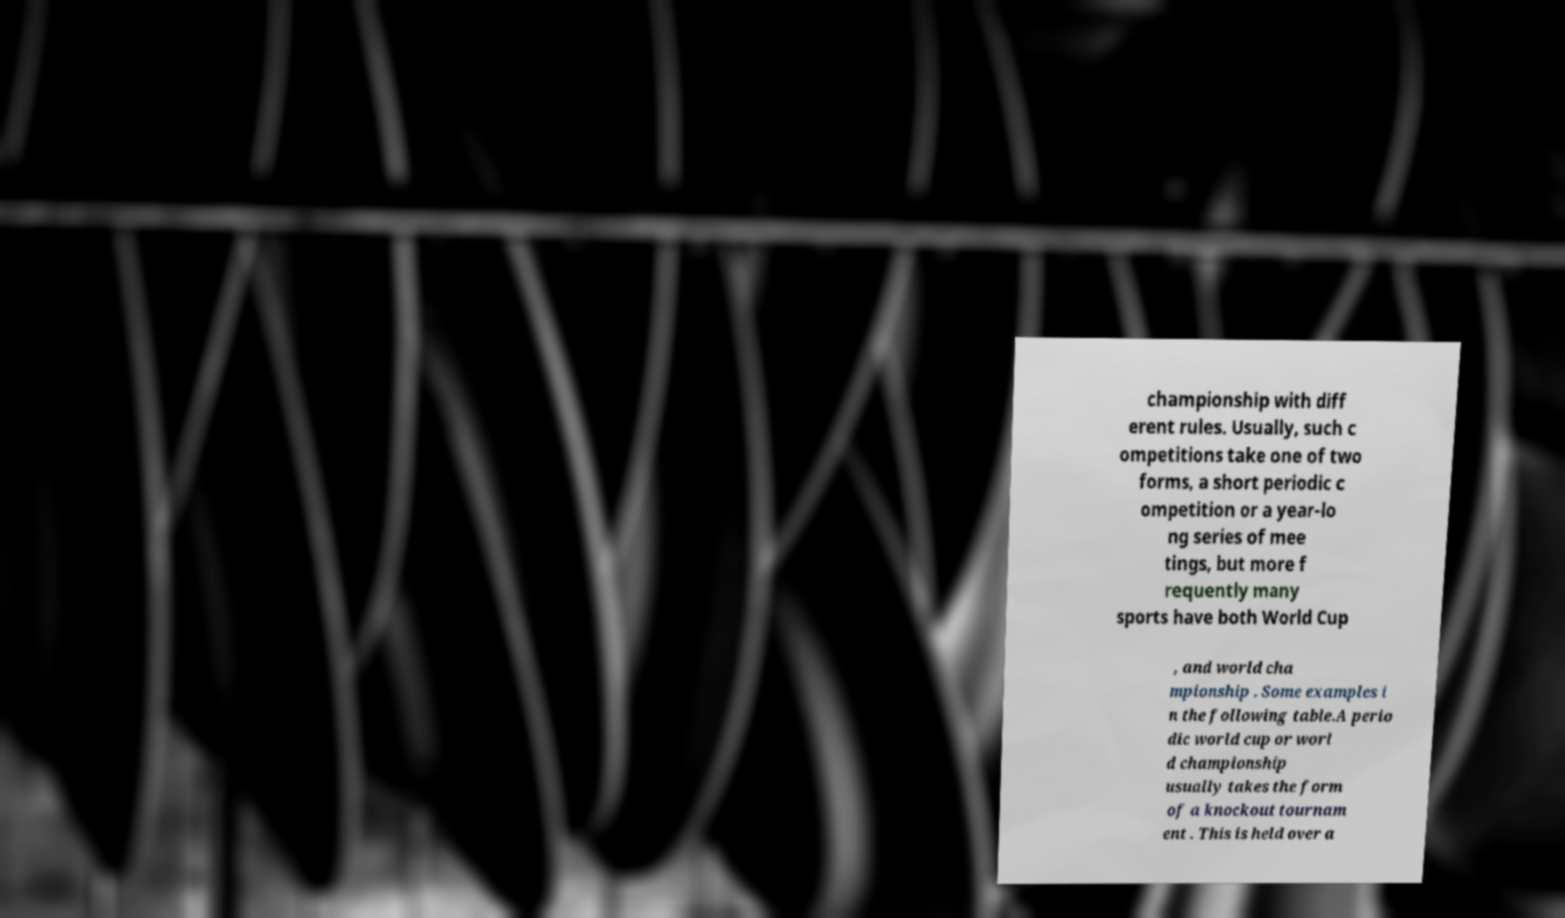What messages or text are displayed in this image? I need them in a readable, typed format. championship with diff erent rules. Usually, such c ompetitions take one of two forms, a short periodic c ompetition or a year-lo ng series of mee tings, but more f requently many sports have both World Cup , and world cha mpionship . Some examples i n the following table.A perio dic world cup or worl d championship usually takes the form of a knockout tournam ent . This is held over a 